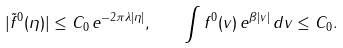Convert formula to latex. <formula><loc_0><loc_0><loc_500><loc_500>| \tilde { f } ^ { 0 } ( \eta ) | \leq C _ { 0 } \, e ^ { - 2 \pi \lambda | \eta | } , \quad \int f ^ { 0 } ( v ) \, e ^ { \beta | v | } \, d v \leq C _ { 0 } .</formula> 